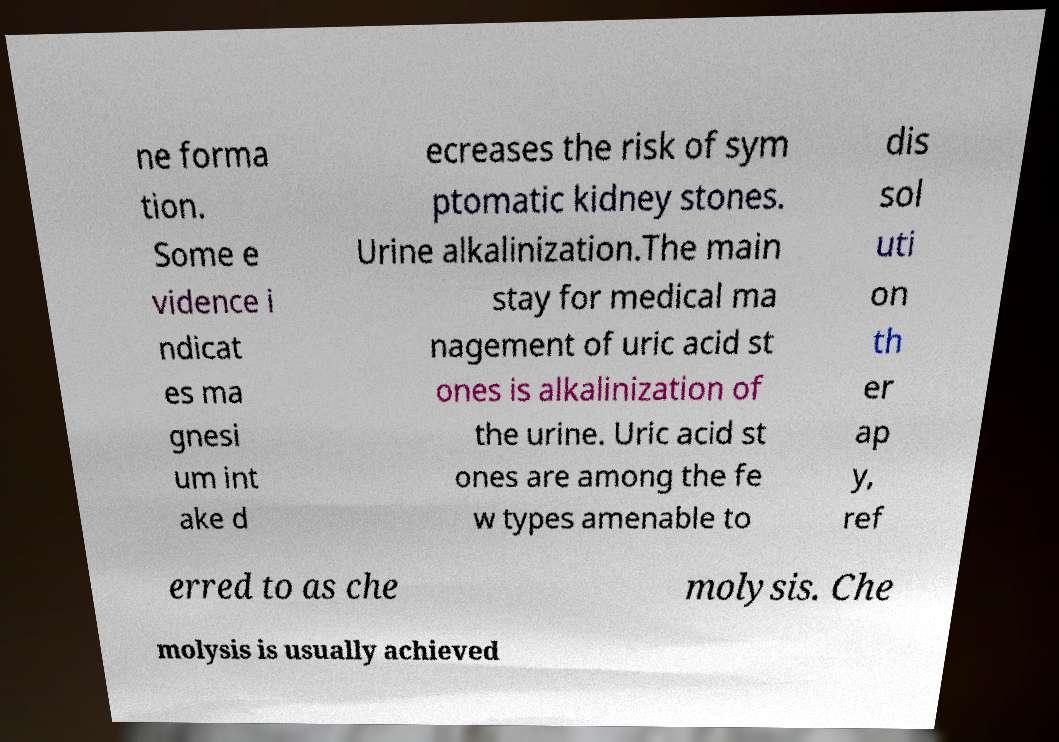I need the written content from this picture converted into text. Can you do that? ne forma tion. Some e vidence i ndicat es ma gnesi um int ake d ecreases the risk of sym ptomatic kidney stones. Urine alkalinization.The main stay for medical ma nagement of uric acid st ones is alkalinization of the urine. Uric acid st ones are among the fe w types amenable to dis sol uti on th er ap y, ref erred to as che molysis. Che molysis is usually achieved 